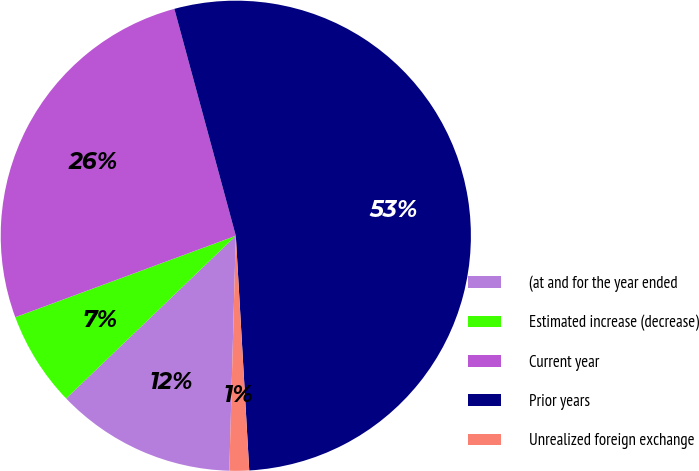Convert chart to OTSL. <chart><loc_0><loc_0><loc_500><loc_500><pie_chart><fcel>(at and for the year ended<fcel>Estimated increase (decrease)<fcel>Current year<fcel>Prior years<fcel>Unrealized foreign exchange<nl><fcel>12.39%<fcel>6.54%<fcel>26.42%<fcel>53.3%<fcel>1.35%<nl></chart> 